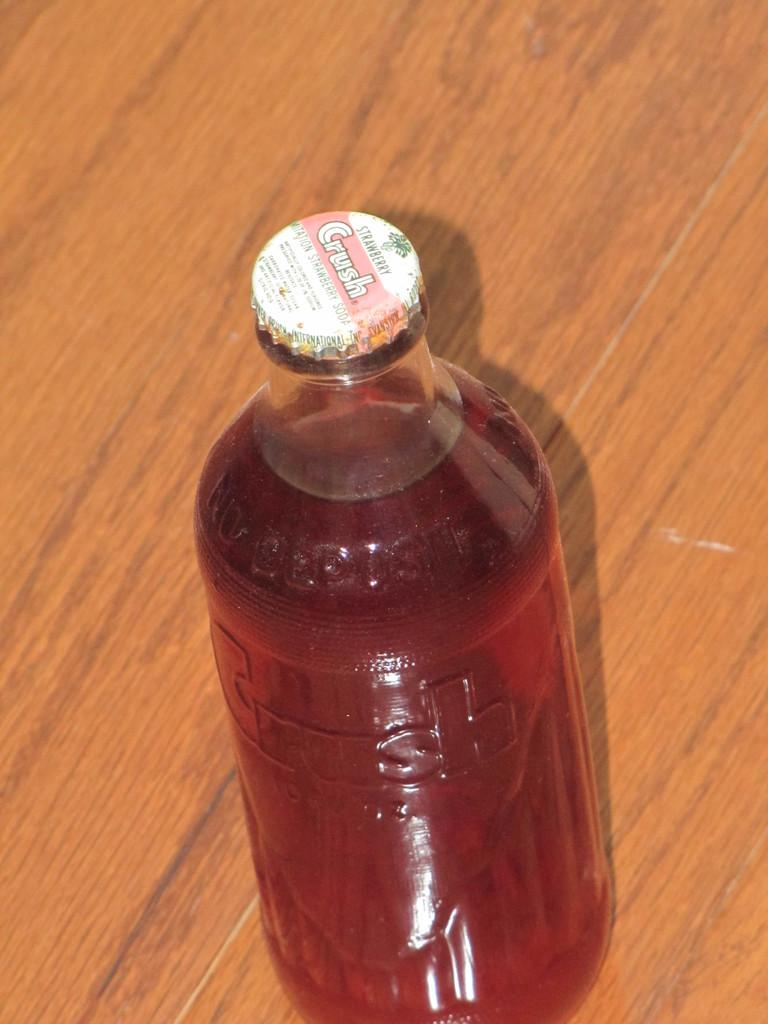<image>
Describe the image concisely. a bottle of Strawberry Crush sits on a wood surface 